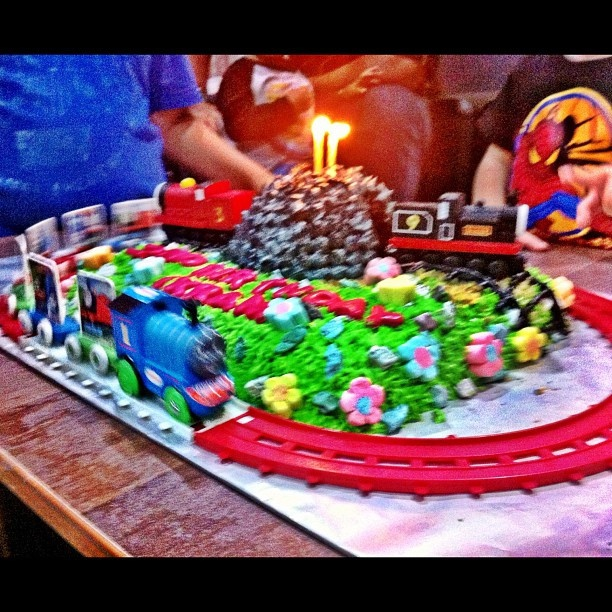Describe the objects in this image and their specific colors. I can see cake in black, lavender, and brown tones, people in black, darkblue, blue, and navy tones, people in black, brown, maroon, and red tones, people in black, maroon, lightpink, and brown tones, and train in black, blue, and lightblue tones in this image. 